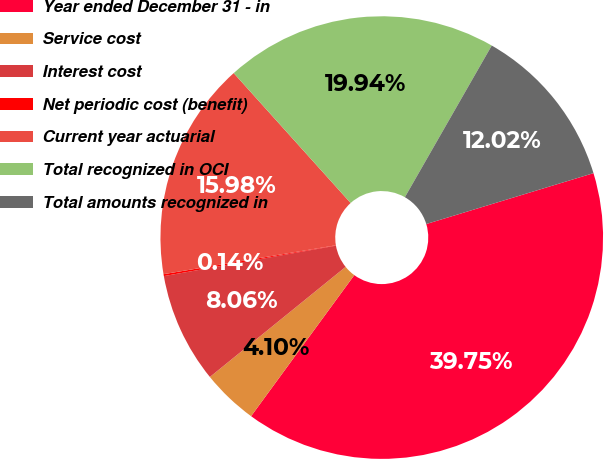Convert chart to OTSL. <chart><loc_0><loc_0><loc_500><loc_500><pie_chart><fcel>Year ended December 31 - in<fcel>Service cost<fcel>Interest cost<fcel>Net periodic cost (benefit)<fcel>Current year actuarial<fcel>Total recognized in OCI<fcel>Total amounts recognized in<nl><fcel>39.75%<fcel>4.1%<fcel>8.06%<fcel>0.14%<fcel>15.98%<fcel>19.94%<fcel>12.02%<nl></chart> 